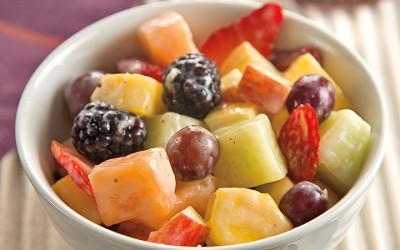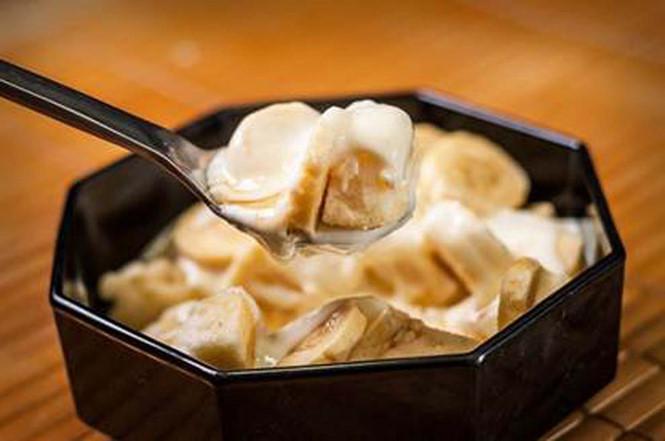The first image is the image on the left, the second image is the image on the right. For the images displayed, is the sentence "The left image shows mixed fruit pieces in a white bowl, and the right image shows sliced bananas in an octagon-shaped black bowl." factually correct? Answer yes or no. Yes. The first image is the image on the left, the second image is the image on the right. Evaluate the accuracy of this statement regarding the images: "there is a white bowl with strawberries bananas and other varying fruits". Is it true? Answer yes or no. No. 